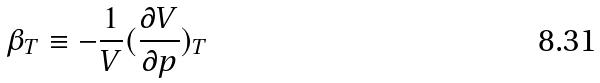<formula> <loc_0><loc_0><loc_500><loc_500>\beta _ { T } \equiv - \frac { 1 } { V } ( \frac { \partial V } { \partial p } ) _ { T }</formula> 